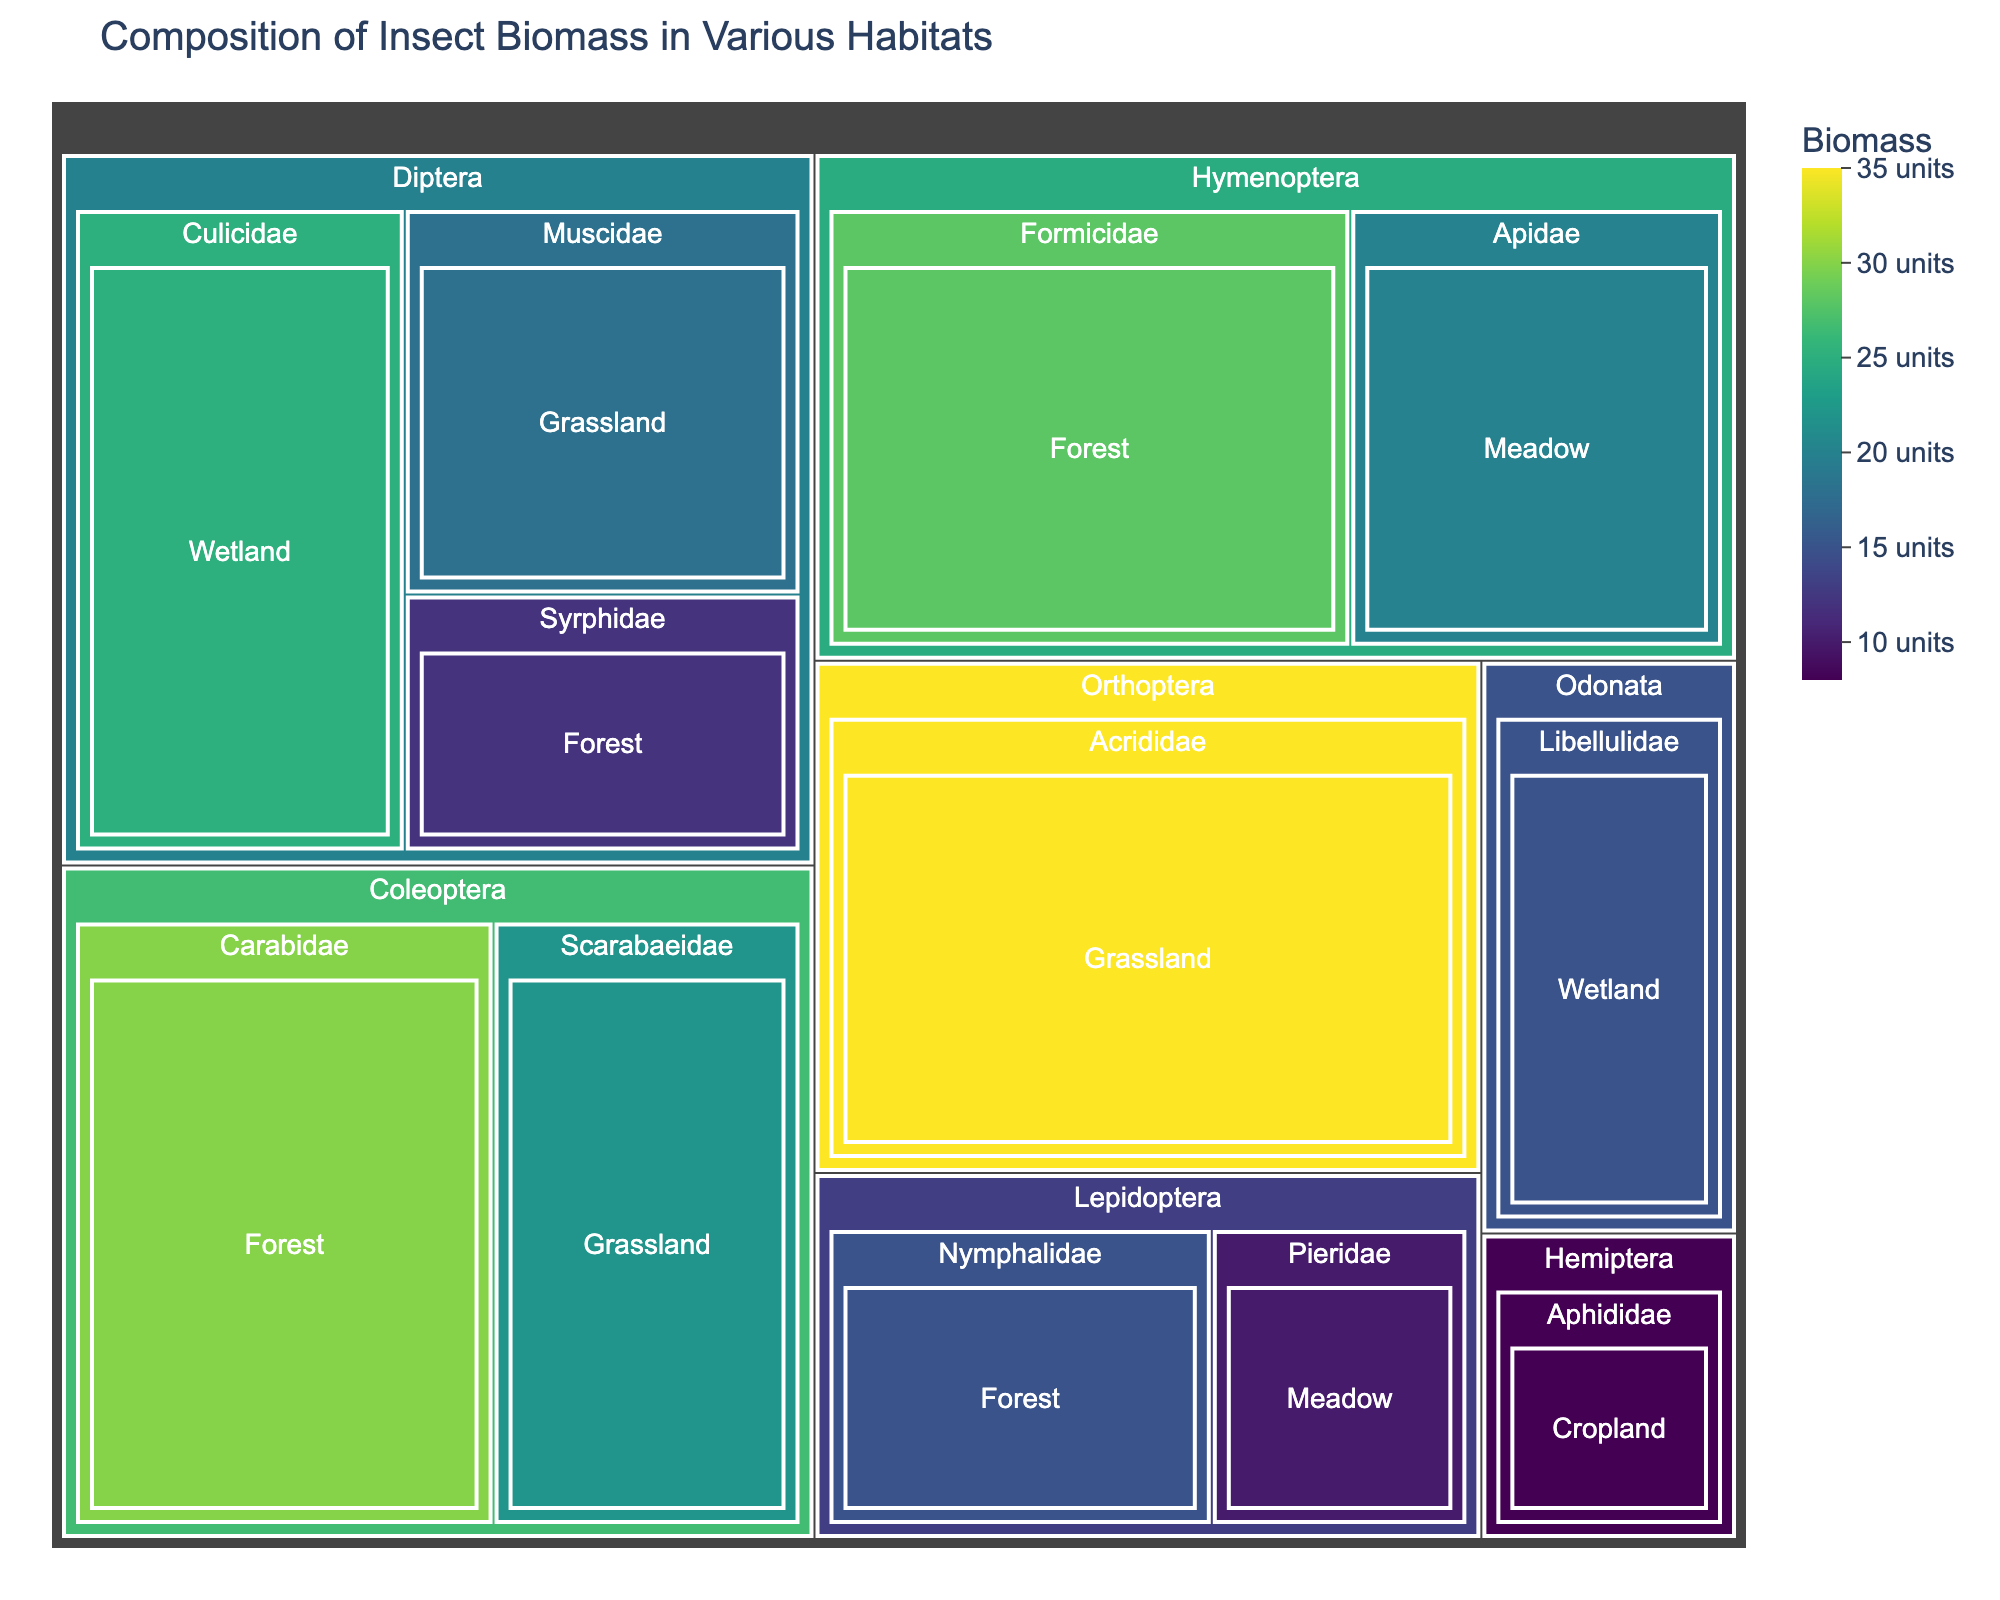What habitat has the highest insect biomass? The treemap will visualize different habitats, each with a corresponding total insect biomass shown by the size or color. Observing these representations, the habitat with the largest or most prominently colored section has the highest biomass.
Answer: Grassland How much biomass do Diptera insects contribute in total across all habitats? Locate all sections in the treemap that represent the order Diptera (Culicidae, Muscidae, Syrphidae) and sum their biomass values: 25 (Culicidae, Wetland) + 18 (Muscidae, Grassland) + 12 (Syrphidae, Forest).
Answer: 55 Which order has the lowest total biomass? Sum up the biomass values for all families of each order and compare them. Orders include Diptera, Coleoptera, Lepidoptera, Hymenoptera, Orthoptera, Hemiptera, Odonata. By observing the summed values: Hemiptera (Aphididae, Cropland) has the lowest total biomass with 8 units.
Answer: Hemiptera Between wetland and forest habitats, which has a greater biomass of Diptera insects? Identify the biomass contributions of Diptera in wetland (Culicidae: 25) and compare with forest (Syrphidae: 12). Wetland has a greater biomass value.
Answer: Wetland Compare the biomass of Coleoptera in grassland and forest habitats. Which one is larger, and by how much? Locate the biomass values for Coleoptera in grassland (Scarabaeidae, 22) and forest (Carabidae, 30). Calculate the difference: 30 - 22 = 8. Forest has a larger biomass by 8 units.
Answer: Forest, by 8 units Is the biomass of Hymenoptera in forest greater than Orthoptera in grassland? Evaluate the biomass of Hymenoptera in forest (Formicidae: 28) and compare it with Orthoptera in grassland (Acrididae: 35). Orthoptera in grassland has a greater biomass.
Answer: No What is the combined biomass of all insects in meadow habitats? Locate and sum the biomass values of insects in meadow (Lepidoptera: Pieridae, 10 + Hymenoptera: Apidae, 20). The total is 10 + 20 = 30.
Answer: 30 Identify the insect family with the highest individual biomass. Which habitat does it belong to? Locate the sections of the treemap representing individual families and observe their biomass values. The family with the highest biomass is Acrididae (Orthoptera) with 35 units, found in grassland.
Answer: Acrididae in Grassland 